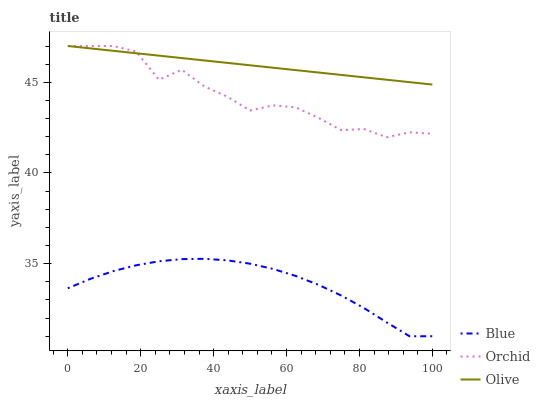Does Orchid have the minimum area under the curve?
Answer yes or no. No. Does Orchid have the maximum area under the curve?
Answer yes or no. No. Is Orchid the smoothest?
Answer yes or no. No. Is Olive the roughest?
Answer yes or no. No. Does Orchid have the lowest value?
Answer yes or no. No. Is Blue less than Olive?
Answer yes or no. Yes. Is Orchid greater than Blue?
Answer yes or no. Yes. Does Blue intersect Olive?
Answer yes or no. No. 